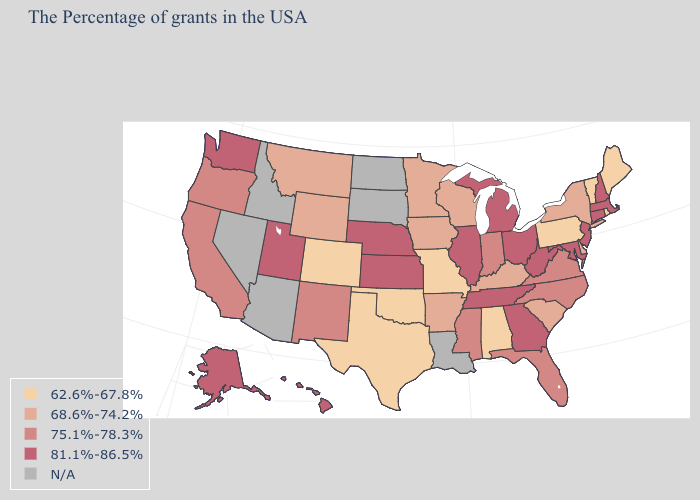What is the value of New Hampshire?
Give a very brief answer. 81.1%-86.5%. Does the first symbol in the legend represent the smallest category?
Concise answer only. Yes. Does New Jersey have the highest value in the USA?
Keep it brief. Yes. Which states hav the highest value in the West?
Be succinct. Utah, Washington, Alaska, Hawaii. Does the map have missing data?
Be succinct. Yes. Does New Hampshire have the lowest value in the Northeast?
Concise answer only. No. Name the states that have a value in the range 81.1%-86.5%?
Write a very short answer. Massachusetts, New Hampshire, Connecticut, New Jersey, Maryland, West Virginia, Ohio, Georgia, Michigan, Tennessee, Illinois, Kansas, Nebraska, Utah, Washington, Alaska, Hawaii. Among the states that border Kentucky , which have the highest value?
Quick response, please. West Virginia, Ohio, Tennessee, Illinois. Name the states that have a value in the range N/A?
Answer briefly. Louisiana, South Dakota, North Dakota, Arizona, Idaho, Nevada. Name the states that have a value in the range 68.6%-74.2%?
Quick response, please. New York, Delaware, South Carolina, Kentucky, Wisconsin, Arkansas, Minnesota, Iowa, Wyoming, Montana. Among the states that border Colorado , which have the highest value?
Be succinct. Kansas, Nebraska, Utah. Does the first symbol in the legend represent the smallest category?
Keep it brief. Yes. Does the map have missing data?
Be succinct. Yes. What is the lowest value in the USA?
Keep it brief. 62.6%-67.8%. 